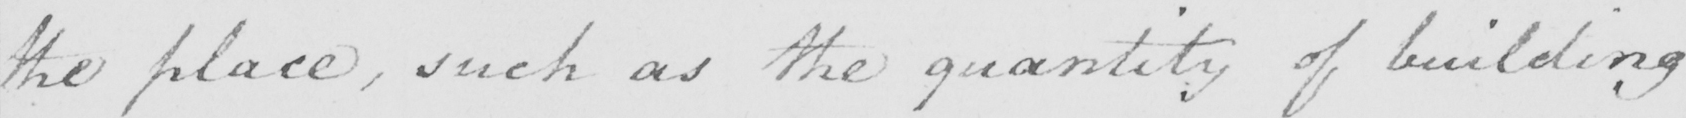What text is written in this handwritten line? the place , such as the quantity of building 